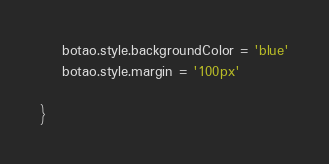Convert code to text. <code><loc_0><loc_0><loc_500><loc_500><_JavaScript_>    botao.style.backgroundColor = 'blue'
    botao.style.margin = '100px'
    
}





</code> 